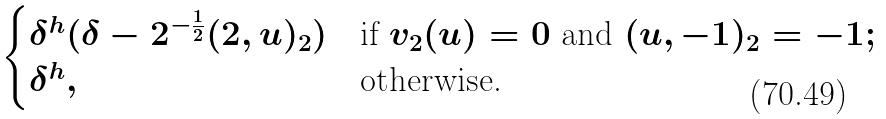<formula> <loc_0><loc_0><loc_500><loc_500>\begin{cases} \delta ^ { h } ( \delta - 2 ^ { - \frac { 1 } { 2 } } ( 2 , u ) _ { 2 } ) & \text {if } v _ { 2 } ( u ) = 0 \text { and } ( u , - 1 ) _ { 2 } = - 1 ; \\ \delta ^ { h } , & \text {otherwise.} \end{cases}</formula> 